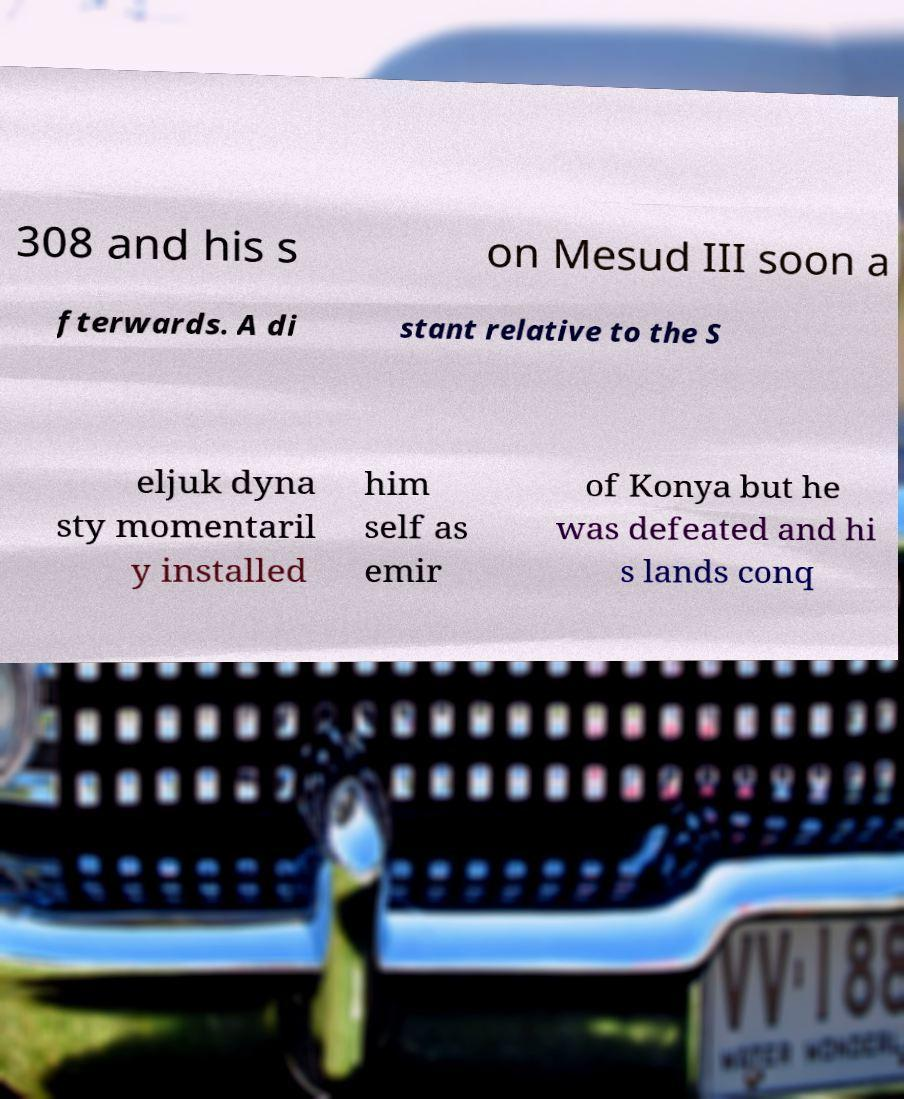For documentation purposes, I need the text within this image transcribed. Could you provide that? 308 and his s on Mesud III soon a fterwards. A di stant relative to the S eljuk dyna sty momentaril y installed him self as emir of Konya but he was defeated and hi s lands conq 